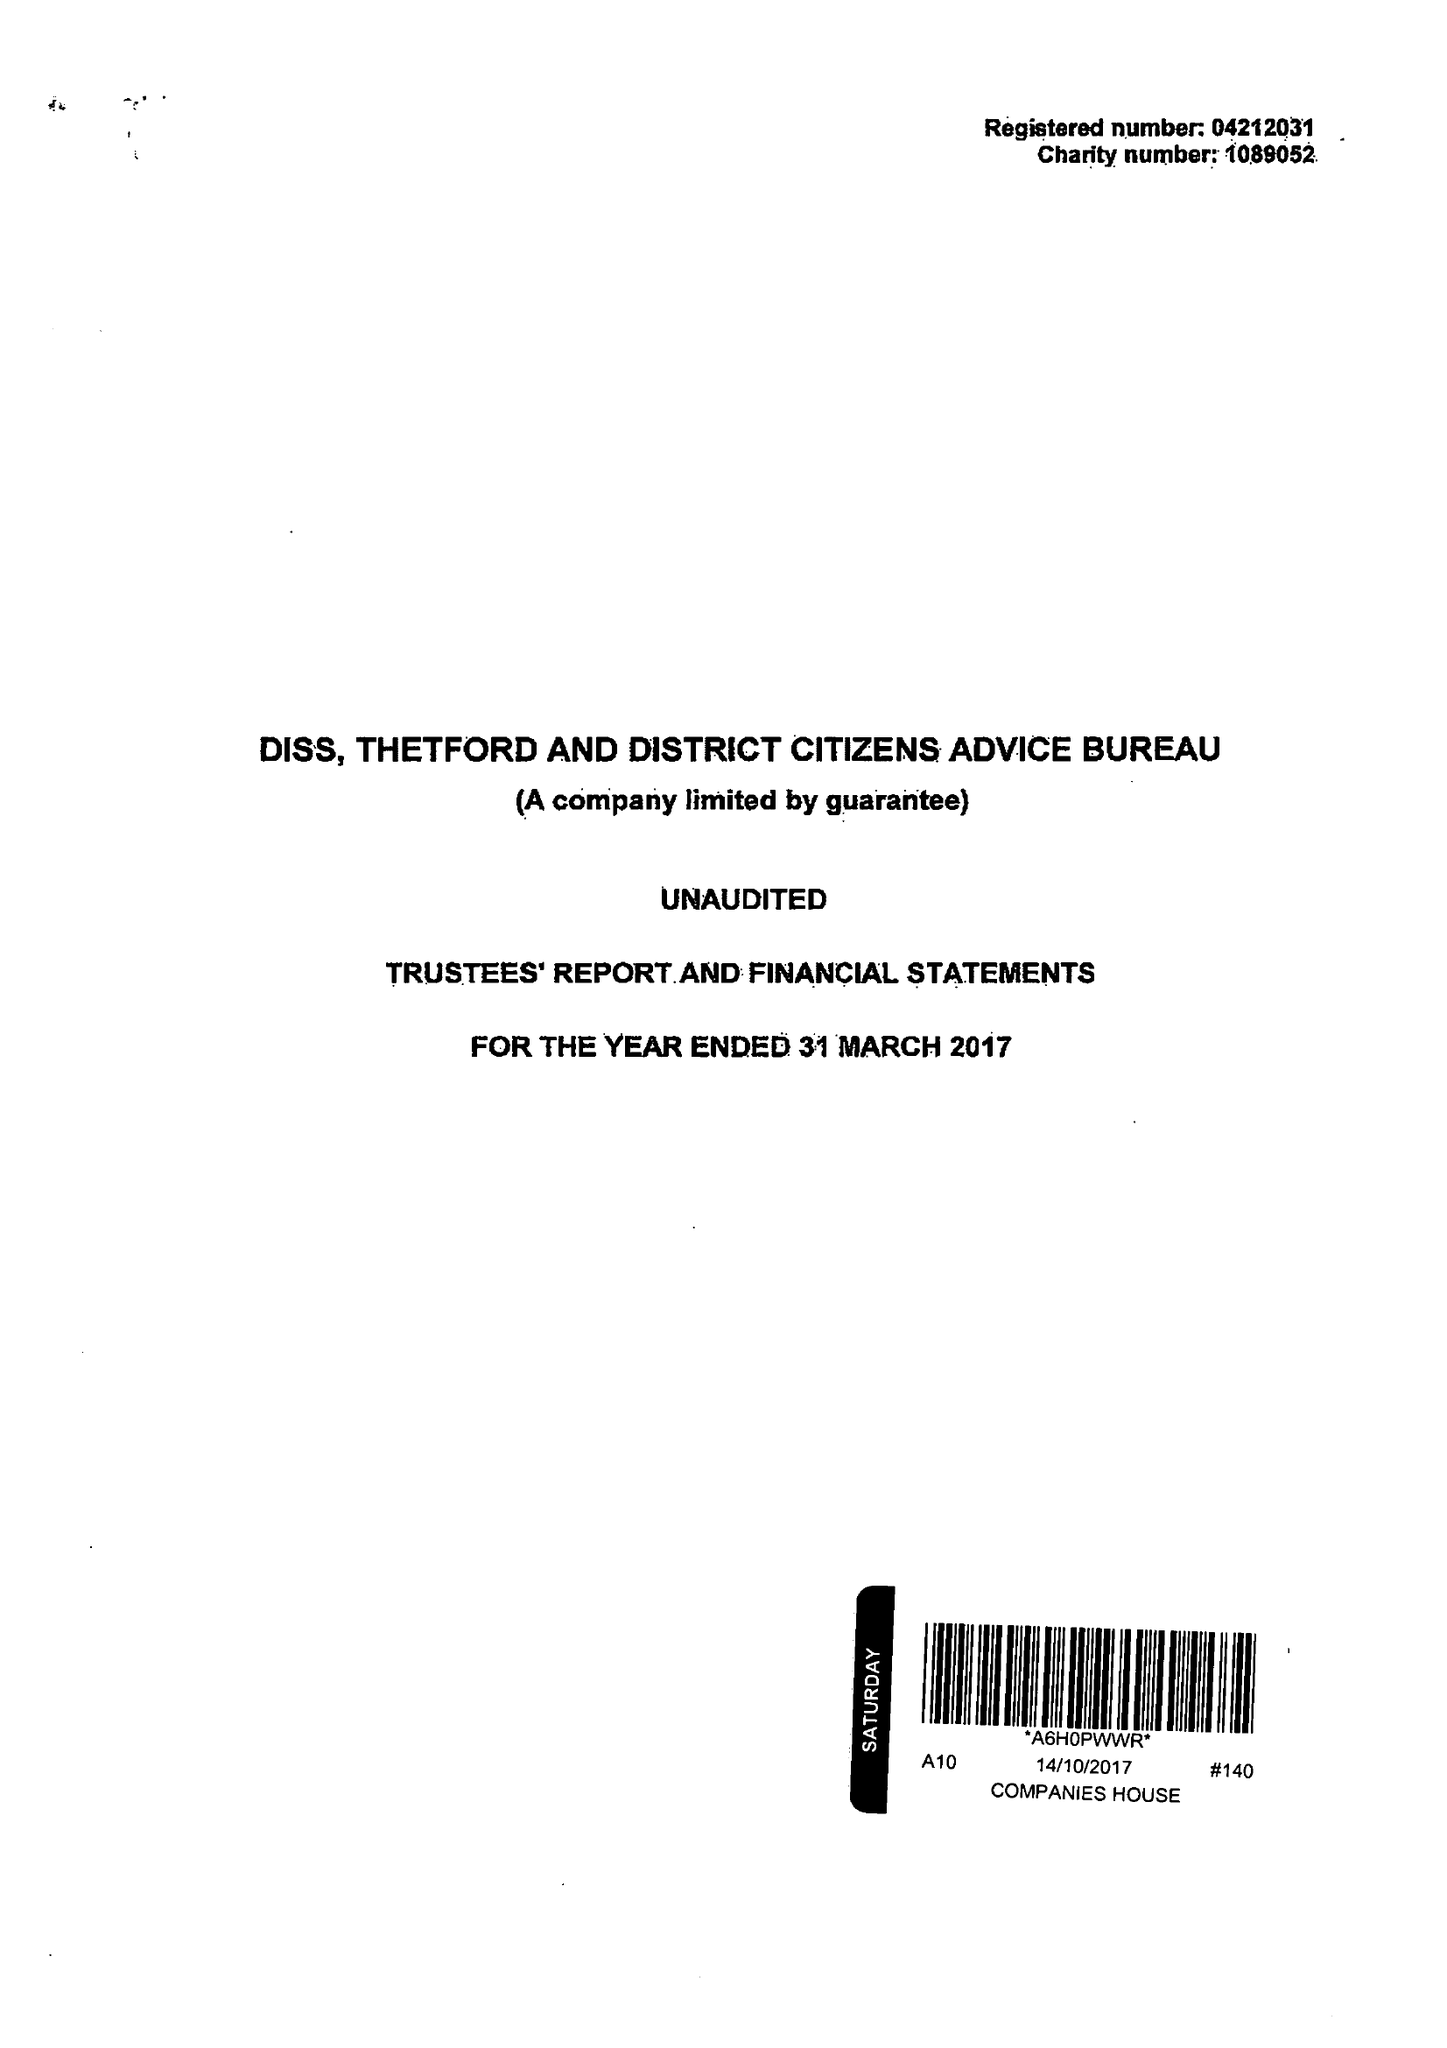What is the value for the spending_annually_in_british_pounds?
Answer the question using a single word or phrase. 429189.00 